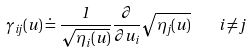Convert formula to latex. <formula><loc_0><loc_0><loc_500><loc_500>\gamma _ { i j } ( u ) \doteq \frac { 1 } { \sqrt { \eta _ { i } ( u ) } } \frac { \partial } { \partial u _ { i } } \sqrt { \eta _ { j } ( u ) } \quad i \neq j</formula> 